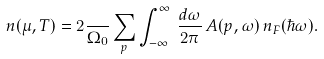<formula> <loc_0><loc_0><loc_500><loc_500>n ( \mu , T ) = 2 \frac { } { \Omega _ { 0 } } \sum _ { p } \int _ { - \infty } ^ { \infty } \, \frac { d \omega } { 2 \pi } \, A ( p , \omega ) \, n _ { F } ( \hbar { \omega } ) .</formula> 